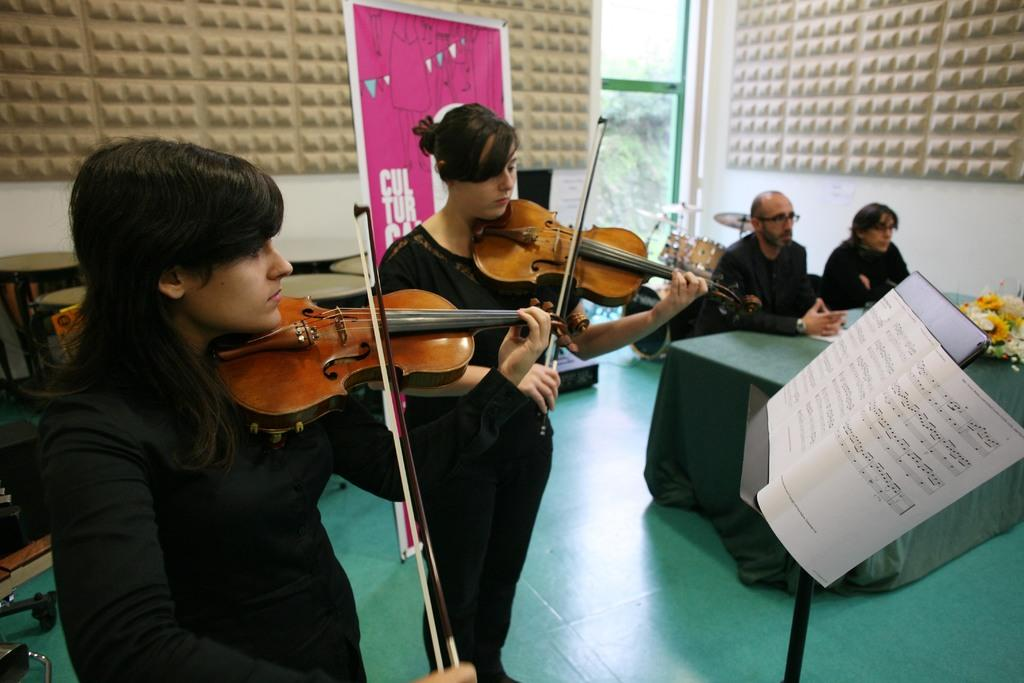What are the two ladies in the image doing? The two ladies are playing violins in the image. What can be seen in the image besides the ladies playing violins? There is a stand, a table, two people sitting on chairs on the right side of the image, and a board in the background of the image. How many hats can be seen on the edge of the table in the image? There are no hats present in the image, and therefore none can be seen on the edge of the table. What is the value of the cent in the image? There is no mention of a cent or any currency in the image. 